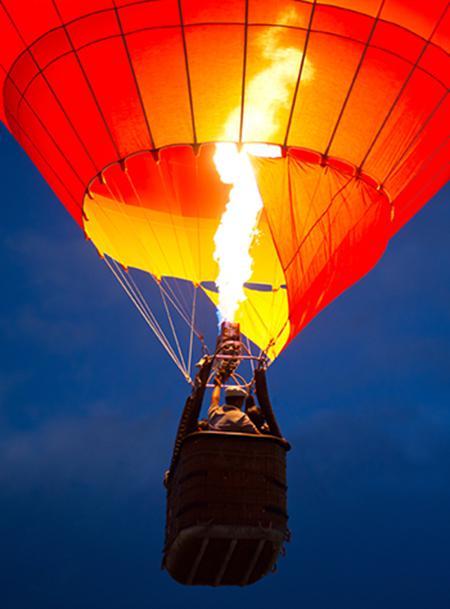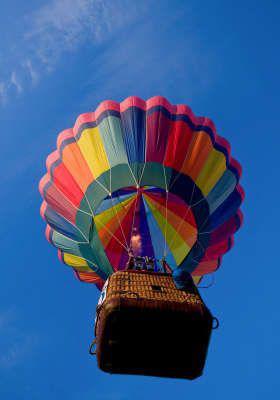The first image is the image on the left, the second image is the image on the right. Analyze the images presented: Is the assertion "In total, two hot-air balloons are shown, each floating in the air." valid? Answer yes or no. Yes. The first image is the image on the left, the second image is the image on the right. For the images shown, is this caption "There are exactly 2 flying balloons." true? Answer yes or no. Yes. 